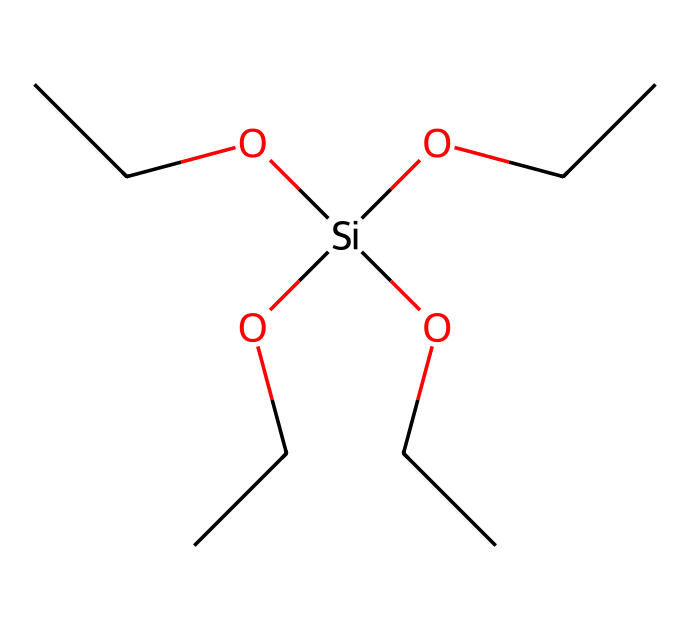What is the main functional group present in tetraethoxysilane? The structure shows that tetraethoxysilane contains four ethoxy groups (-OCC) attached to the silicon atom, making the -OCC groups the main functional group.
Answer: ethoxy group How many carbon atoms are in the tetraethoxysilane molecule? Each ethoxy group (-OCC) contains two carbon atoms, and there are four such groups, thus giving 2 x 4 = 8 carbon atoms total in the molecule.
Answer: 8 What is the total number of silicon atoms in this structure? The structure includes one silicon atom, which can be identified by the 'Si' in the SMILES notation.
Answer: 1 How many oxygen atoms are present in tetraethoxysilane? Each ethoxy group contributes one oxygen atom, and with four ethoxy groups, the total count of oxygen atoms is 4 (1 from each -OCC group).
Answer: 4 What type of chemical compound is tetraethoxysilane classified as? Given its structure which includes a silicon atom bonded to multiple ethoxy groups, tetraethoxysilane is classified as a silane.
Answer: silane How does the presence of ethoxy groups influence the reactivity of tetraethoxysilane? The ethoxy groups enhance the hydrophilicity and promote reactions with water, important in stone and masonry preservation, as they hydrolyze to form silanol groups.
Answer: enhances reactivity What is the role of tetraethoxysilane in stone and masonry preservation? Tetraethoxysilane acts as a bonding agent when it hydrolyzes, forming a silanol that helps to consolidate and protect porous stone and masonry materials.
Answer: bonding agent 